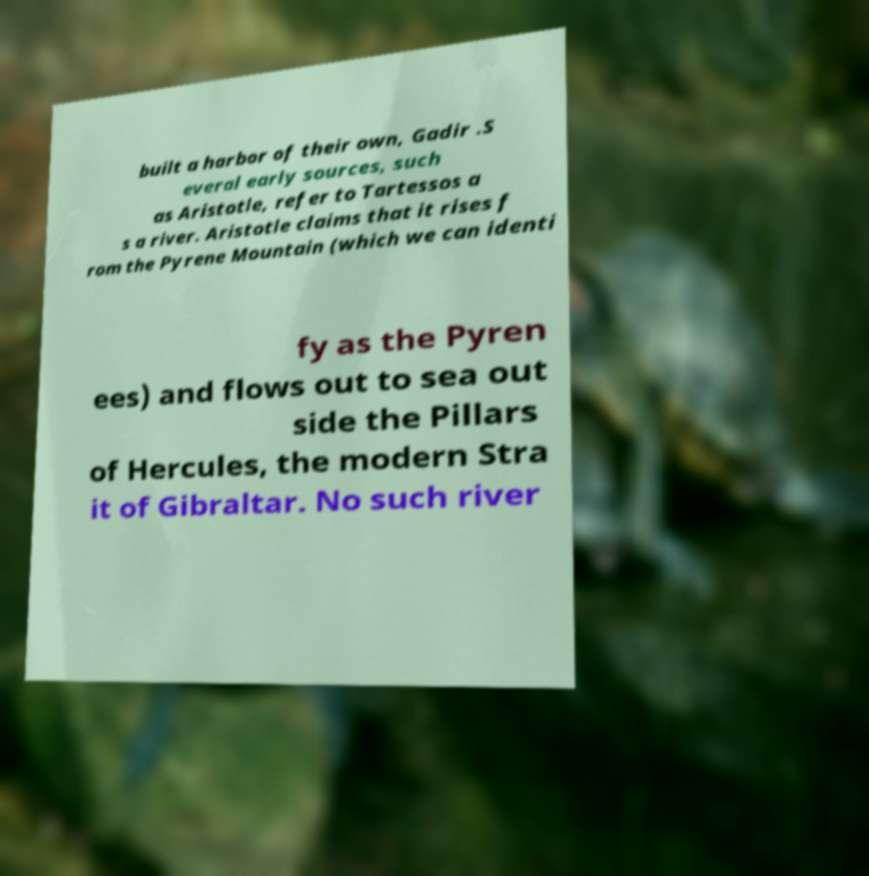What messages or text are displayed in this image? I need them in a readable, typed format. built a harbor of their own, Gadir .S everal early sources, such as Aristotle, refer to Tartessos a s a river. Aristotle claims that it rises f rom the Pyrene Mountain (which we can identi fy as the Pyren ees) and flows out to sea out side the Pillars of Hercules, the modern Stra it of Gibraltar. No such river 